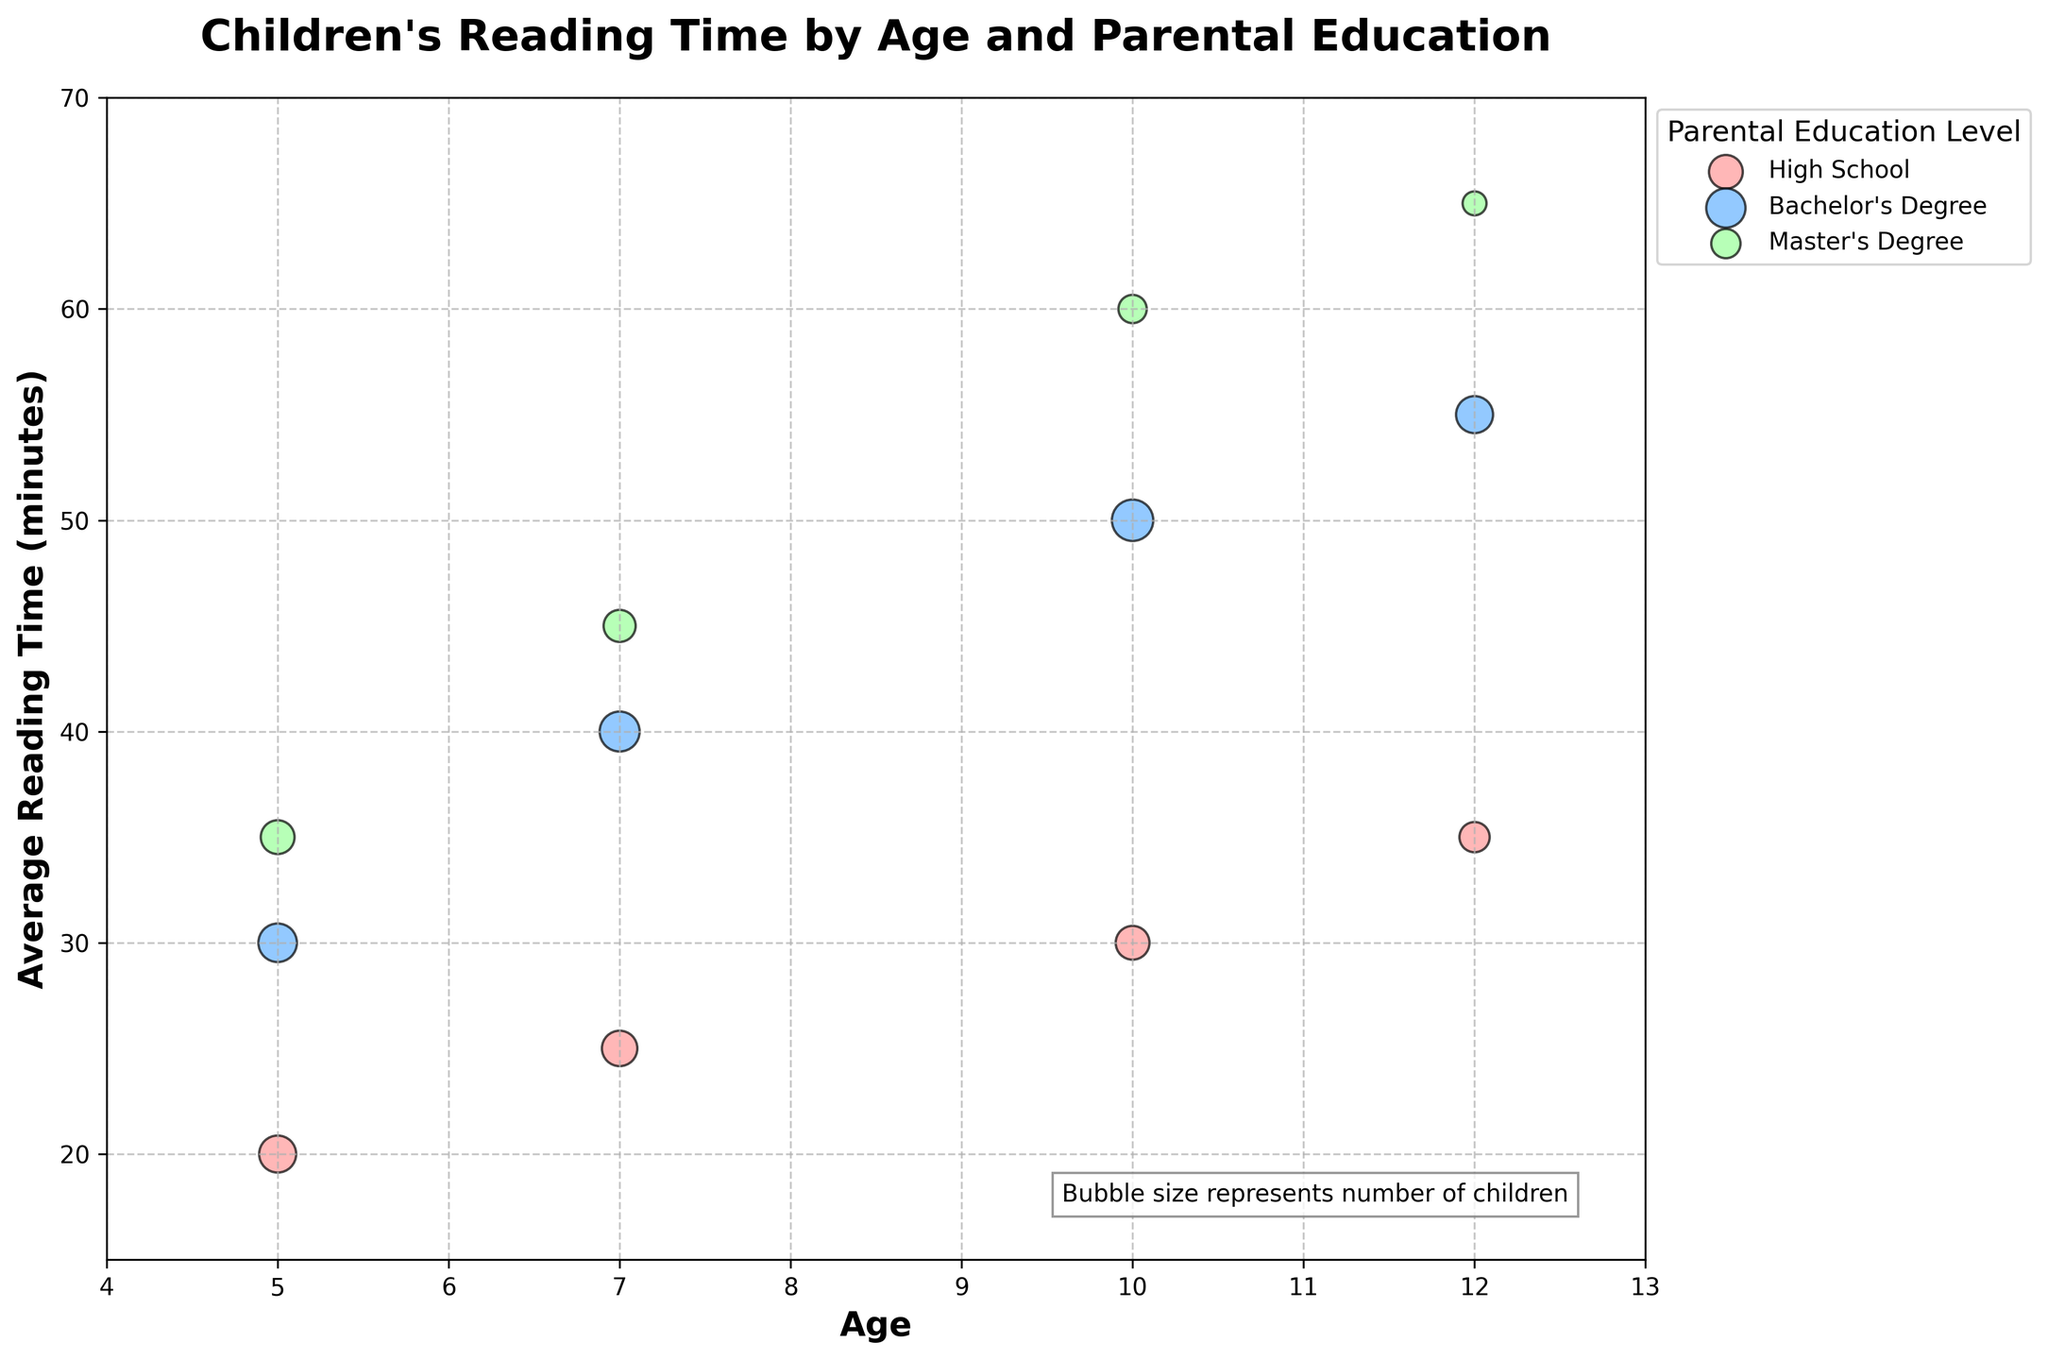How many parental education levels are represented in the chart? The legend displays three colors representing the different parental education levels. Each color corresponds to a specific education level: High School, Bachelor's Degree, and Master's Degree.
Answer: Three What is the average reading time for children aged 10 with parents who have a Master's Degree? Locate the data point where the age is 10 and the parental education level is Master's Degree. The Y-axis indicates their average reading time is 60 minutes.
Answer: 60 minutes What is the size of the bubble for children aged 7 with parents who completed high school only? Find the bubble for age 7 and High School education. The size of the bubble represents 110 children (indicated in the dataset).
Answer: 110 children Compare the average reading time for children aged 12 whose parents have a Bachelor's Degree to those whose parents have a Master's Degree. Locate the bubbles for age 12 with parental education levels of Bachelor's Degree and Master's Degree. The Y-axis shows the average reading times are 55 minutes and 65 minutes respectively.
Answer: 55 minutes vs. 65 minutes Which age group has the largest number of children with parents who have a Bachelor's Degree? Compare the sizes of all the bubbles representing children with parents who have a Bachelor's Degree across different age groups. The largest bubble for Bachelor's Degree is at age 10, with 150 children.
Answer: Age 10 What color represents the highest average reading time for any age group? Identify the colors associated with the highest data points across all age groups on the Y-axis. The highest average reading time is 65 minutes for Master's Degree, which is represented by a green color in the chart.
Answer: Green What is the difference in average reading time between children aged 10 with parents who have a High School education and a Bachelor's Degree? Locate the bubbles for age 10 with High School and Bachelor's Degree parental education. The Y-axis shows average reading times of 30 minutes and 50 minutes respectively. The difference is 50 - 30 = 20 minutes.
Answer: 20 minutes How does the average reading time change with increasing age for children with parents who have a Master's Degree? Track the bubbles for parental Master's Degree across different ages. Average reading times incrementally increase from 35 minutes at age 5, to 45 minutes at age 7, 60 minutes at age 10, and 65 minutes at age 12.
Answer: Increase What trend is observed in the average reading time of children aged 7 with different parental education levels? For age 7, compare the average reading times across different parental education levels. High School shows 25 minutes, Bachelor's Degree shows 40 minutes, and Master's Degree shows 45 minutes. This indicates a positive correlation between higher parental education levels and average reading time.
Answer: Positive correlation 